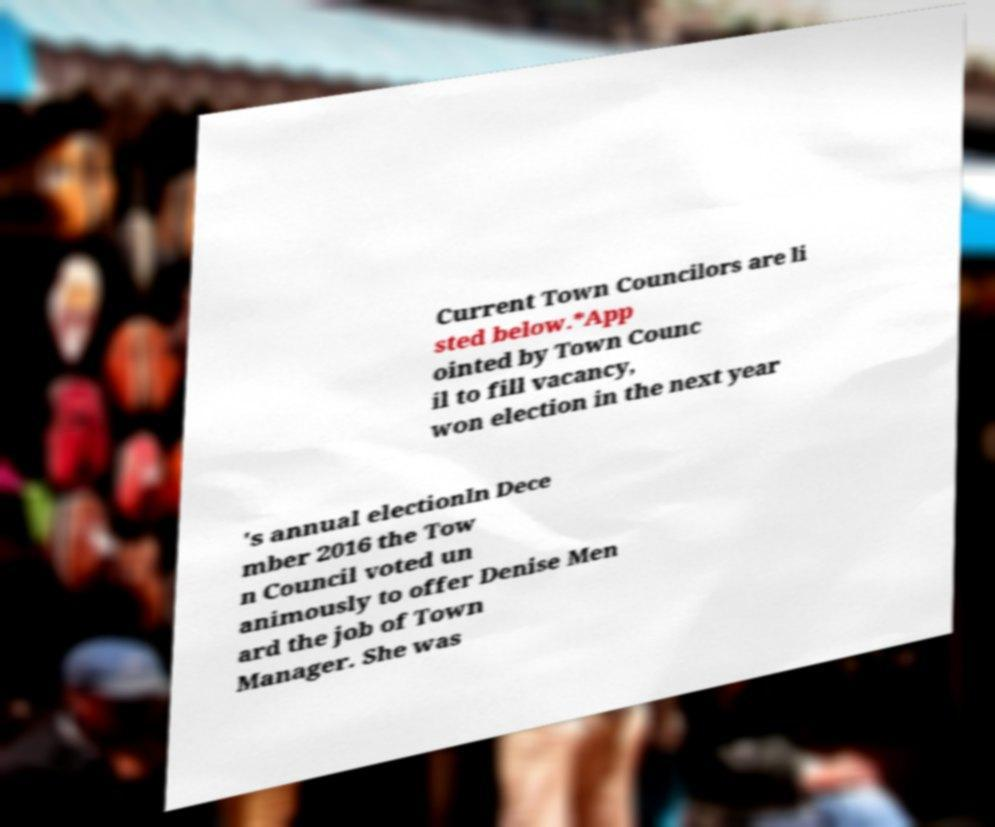Can you read and provide the text displayed in the image?This photo seems to have some interesting text. Can you extract and type it out for me? Current Town Councilors are li sted below.*App ointed by Town Counc il to fill vacancy, won election in the next year 's annual electionIn Dece mber 2016 the Tow n Council voted un animously to offer Denise Men ard the job of Town Manager. She was 